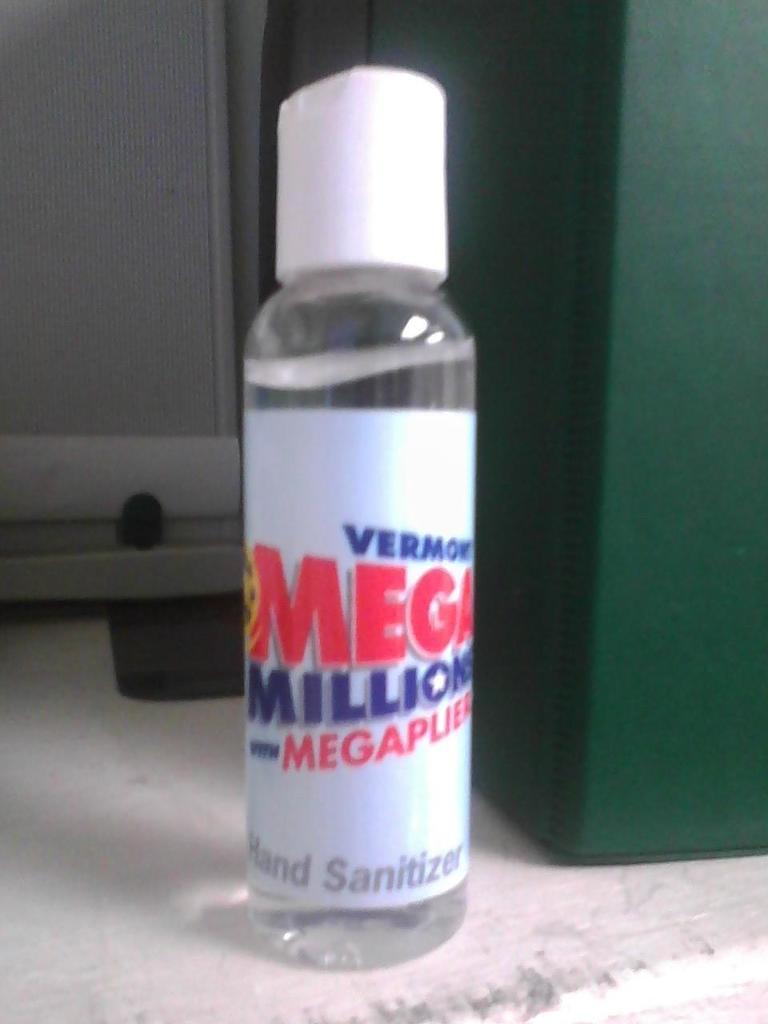Is this hand sanitizer?
Provide a short and direct response. Yes. What is in the bottle?
Give a very brief answer. Hand sanitizer. 